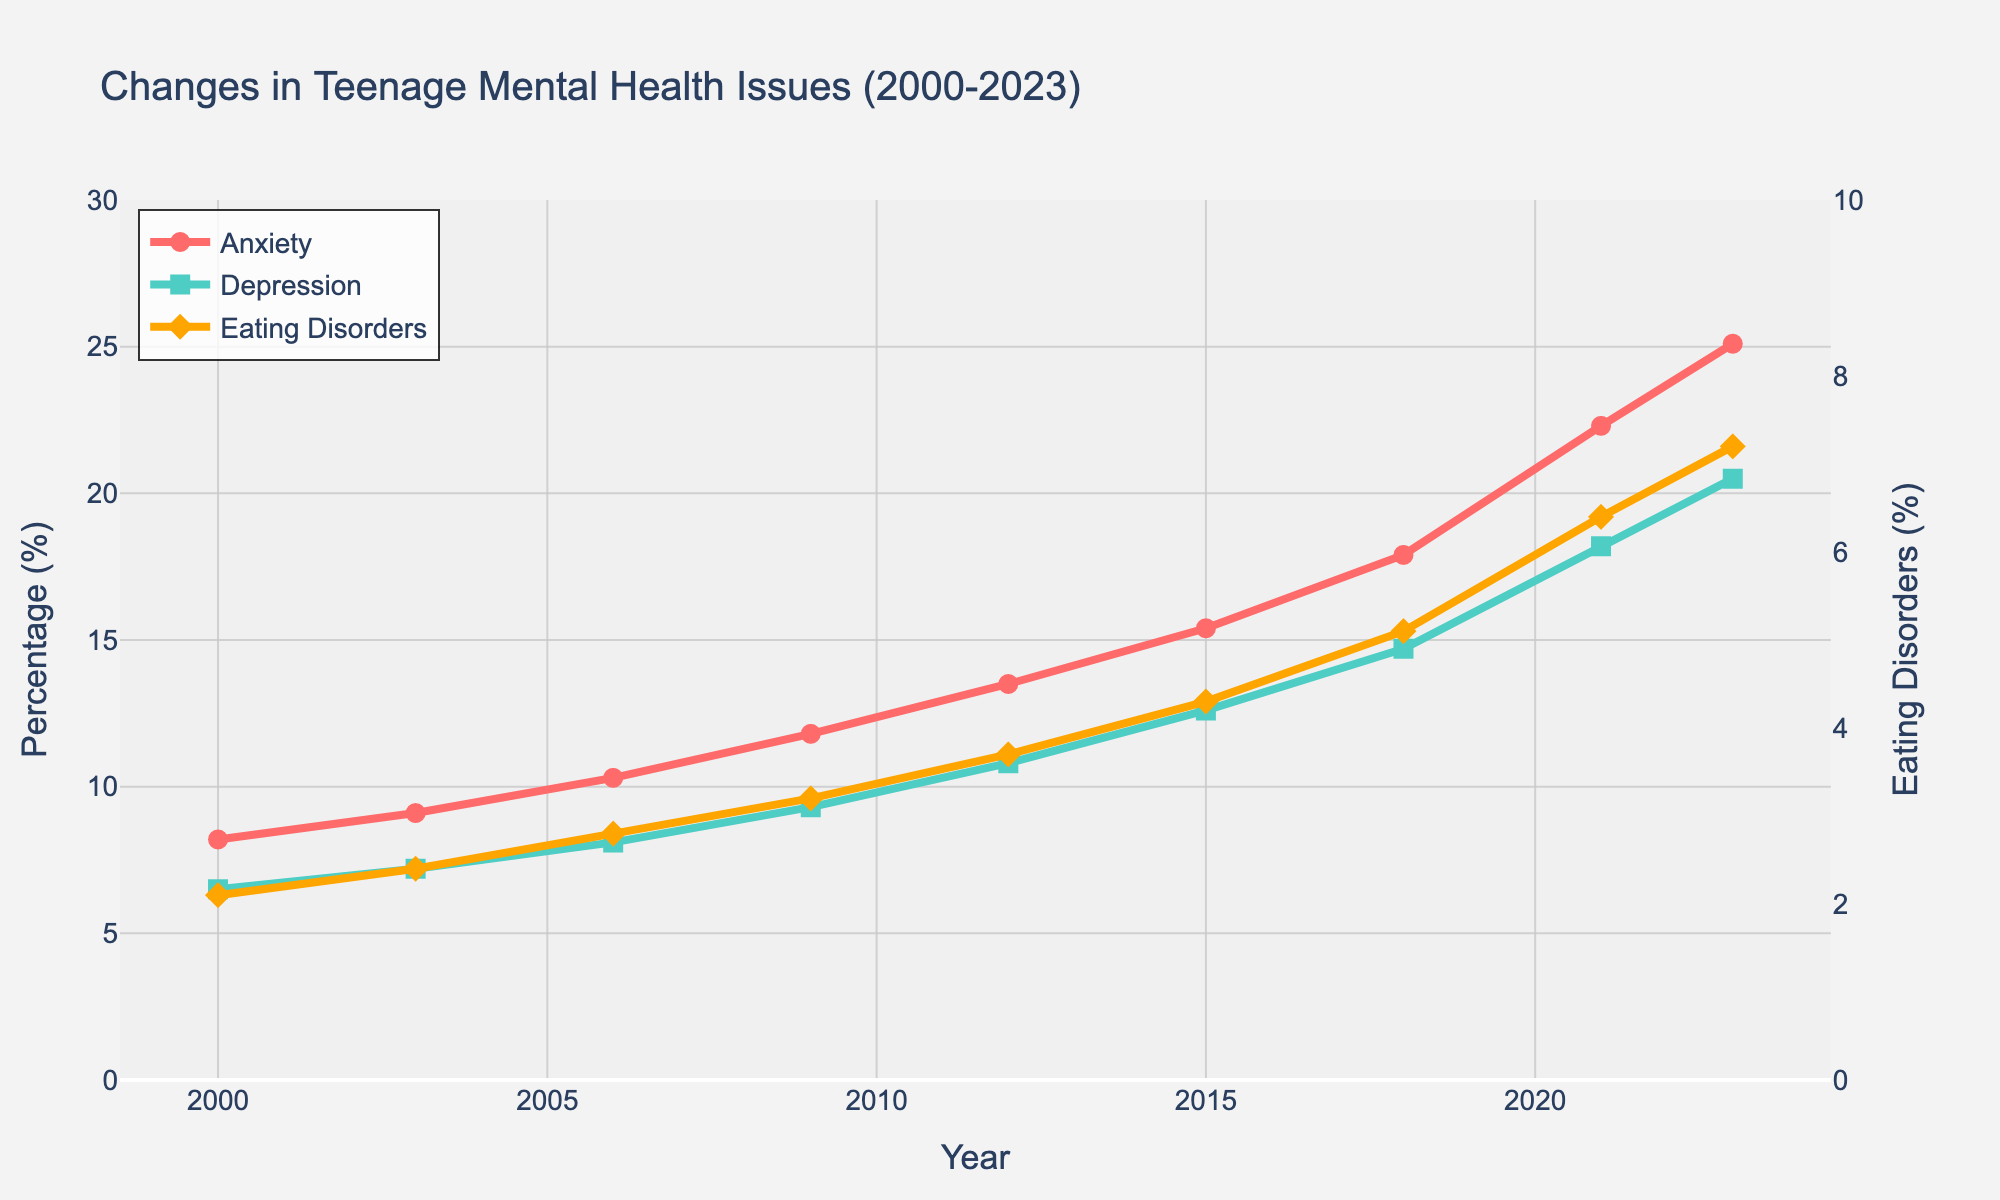Which mental health issue saw the highest percentage increase between 2000 and 2023? We can calculate the percentage increase for each mental health issue by subtracting the 2000 value from the 2023 value and then dividing by the 2000 value, finally multiplying by 100 to get the percentage. For anxiety, it's [(25.1 - 8.2) / 8.2] * 100 = 206.1%. For depression, it's [(20.5 - 6.5) / 6.5] * 100 = 215.4%. For eating disorders, it's [(7.2 - 2.1) / 2.1] * 100 = 242.9%. The highest percentage increase is for eating disorders, at 242.9%.
Answer: Eating disorders By how many percentage points did anxiety increase from 2009 to 2023? From the plot, anxiety in 2009 was 11.8% and in 2023 it is 25.1%. The increase in percentage points is calculated by subtracting the 2009 value from the 2023 value: 25.1 - 11.8 = 13.3 percentage points.
Answer: 13.3 percentage points In which year did depression surpass 10%? Referring to the plot, depression surpassed 10% in the year marked as having a depression rate just over 10%, which is in 2012 (10.8%).
Answer: 2012 Which mental health issue showed the most consistent increase over the years? All three lines in the plot indicate a steady increase, but a closer inspection shows the smoothness and uniformity of the slopes. Anxiety, represented by the red line, appears to have the most uniform slope, indicating the most consistent increase.
Answer: Anxiety What was the difference in the rates of eating disorders between 2003 and 2021? According to the plot, the rate of eating disorders in 2003 was 2.4%, and in 2021 it was 6.4%. The difference is calculated by subtracting the 2003 value from the 2021 value: 6.4 - 2.4 = 4 percentage points.
Answer: 4 percentage points Compare the rates of anxiety and depression in 2018. Which was higher and by how much? In the plot, anxiety in 2018 was 17.9%, and depression was 14.7%. Anxiety was higher than depression by 17.9 - 14.7 = 3.2 percentage points.
Answer: Anxiety by 3.2 percentage points If we calculate the average rate for anxiety from 2000 to 2023, what is the value? To calculate the average rate, sum the percentage rates of anxiety for all years and then divide by the number of years (9): (8.2 + 9.1 + 10.3 + 11.8 + 13.5 + 15.4 + 17.9 + 22.3 + 25.1) / 9 = 15.04%.
Answer: 15.04% Which year marked the highest percentage point increase for depression compared with the previous recorded year? By examining each consecutive pair of years for depression, the highest increase is between 2018 (14.7%) and 2021 (18.2%), which is 18.2 - 14.7 = 3.5 percentage points.
Answer: 2021 Is there a year where the rate of both anxiety and depression was increasing while eating disorders remained the same? Referring to the plot, all three issues show consistent year-on-year increases and there is no point where eating disorders remain the same while both anxiety and depression increase.
Answer: No 